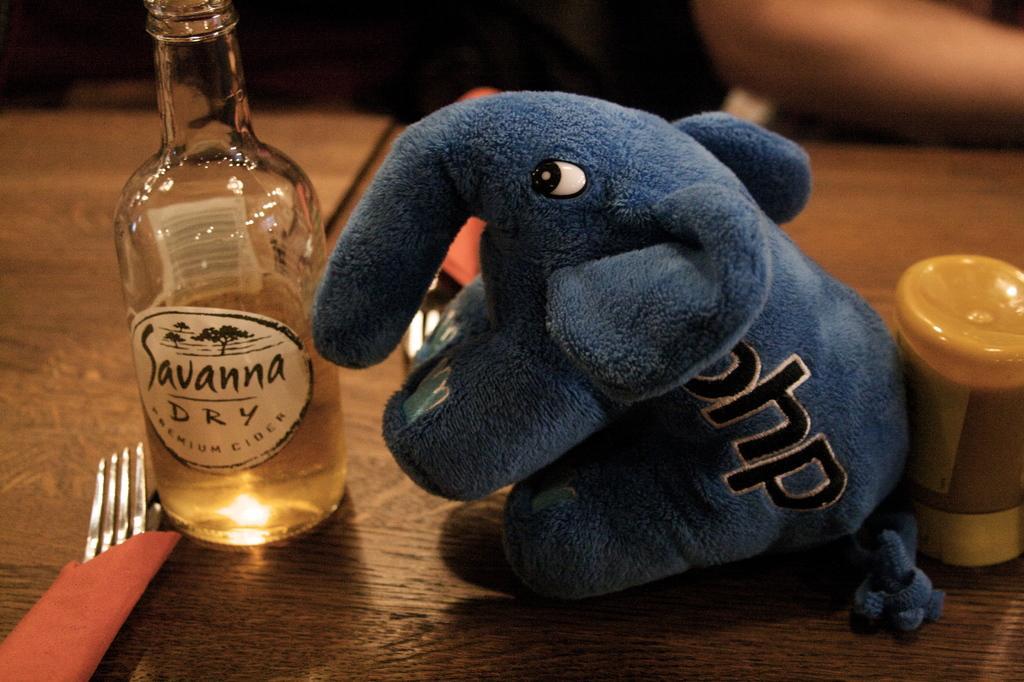In one or two sentences, can you explain what this image depicts? On the background we can see a human's hand. We can see a bottle, elephant doll, a container, fork on the table. 